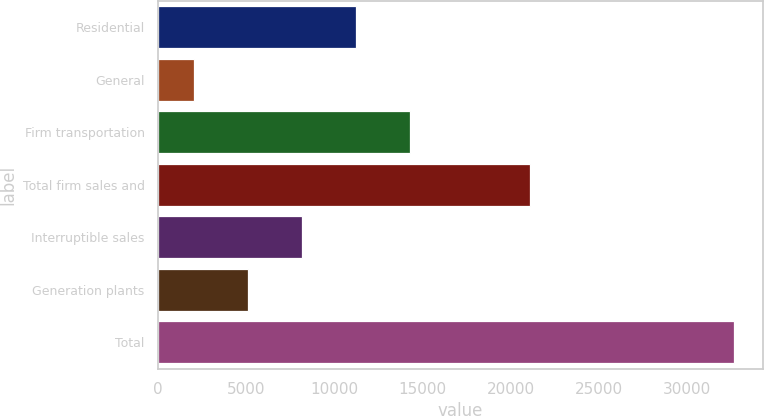<chart> <loc_0><loc_0><loc_500><loc_500><bar_chart><fcel>Residential<fcel>General<fcel>Firm transportation<fcel>Total firm sales and<fcel>Interruptible sales<fcel>Generation plants<fcel>Total<nl><fcel>11244.5<fcel>2066<fcel>14304<fcel>21082<fcel>8185<fcel>5125.5<fcel>32661<nl></chart> 